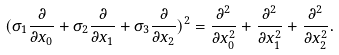<formula> <loc_0><loc_0><loc_500><loc_500>( \sigma _ { 1 } \frac { \partial } { \partial x _ { 0 } } + \sigma _ { 2 } \frac { \partial } { \partial x _ { 1 } } + \sigma _ { 3 } \frac { \partial } { \partial x _ { 2 } } ) ^ { 2 } = \frac { \partial ^ { 2 } } { \partial x _ { 0 } ^ { 2 } } + \frac { \partial ^ { 2 } } { \partial x _ { 1 } ^ { 2 } } + \frac { \partial ^ { 2 } } { \partial x _ { 2 } ^ { 2 } } .</formula> 